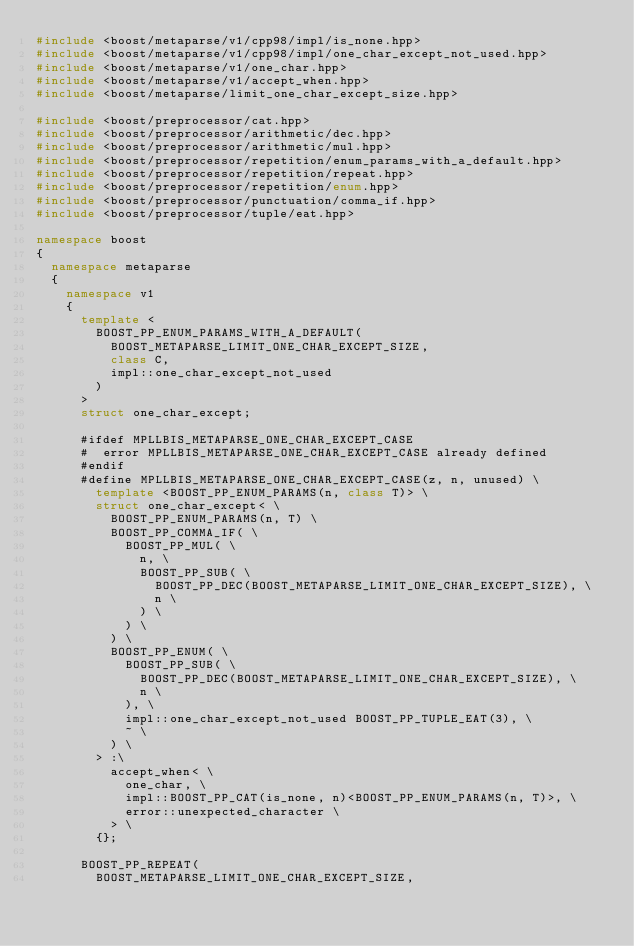Convert code to text. <code><loc_0><loc_0><loc_500><loc_500><_C++_>#include <boost/metaparse/v1/cpp98/impl/is_none.hpp>
#include <boost/metaparse/v1/cpp98/impl/one_char_except_not_used.hpp>
#include <boost/metaparse/v1/one_char.hpp>
#include <boost/metaparse/v1/accept_when.hpp>
#include <boost/metaparse/limit_one_char_except_size.hpp>

#include <boost/preprocessor/cat.hpp>
#include <boost/preprocessor/arithmetic/dec.hpp>
#include <boost/preprocessor/arithmetic/mul.hpp>
#include <boost/preprocessor/repetition/enum_params_with_a_default.hpp>
#include <boost/preprocessor/repetition/repeat.hpp>
#include <boost/preprocessor/repetition/enum.hpp>
#include <boost/preprocessor/punctuation/comma_if.hpp>
#include <boost/preprocessor/tuple/eat.hpp>

namespace boost
{
  namespace metaparse
  {
    namespace v1
    {
      template <
        BOOST_PP_ENUM_PARAMS_WITH_A_DEFAULT(
          BOOST_METAPARSE_LIMIT_ONE_CHAR_EXCEPT_SIZE,
          class C,
          impl::one_char_except_not_used
        )
      >
      struct one_char_except;

      #ifdef MPLLBIS_METAPARSE_ONE_CHAR_EXCEPT_CASE
      #  error MPLLBIS_METAPARSE_ONE_CHAR_EXCEPT_CASE already defined
      #endif
      #define MPLLBIS_METAPARSE_ONE_CHAR_EXCEPT_CASE(z, n, unused) \
        template <BOOST_PP_ENUM_PARAMS(n, class T)> \
        struct one_char_except< \
          BOOST_PP_ENUM_PARAMS(n, T) \
          BOOST_PP_COMMA_IF( \
            BOOST_PP_MUL( \
              n, \
              BOOST_PP_SUB( \
                BOOST_PP_DEC(BOOST_METAPARSE_LIMIT_ONE_CHAR_EXCEPT_SIZE), \
                n \
              ) \
            ) \
          ) \
          BOOST_PP_ENUM( \
            BOOST_PP_SUB( \
              BOOST_PP_DEC(BOOST_METAPARSE_LIMIT_ONE_CHAR_EXCEPT_SIZE), \
              n \
            ), \
            impl::one_char_except_not_used BOOST_PP_TUPLE_EAT(3), \
            ~ \
          ) \
        > :\
          accept_when< \
            one_char, \
            impl::BOOST_PP_CAT(is_none, n)<BOOST_PP_ENUM_PARAMS(n, T)>, \
            error::unexpected_character \
          > \
        {};

      BOOST_PP_REPEAT(
        BOOST_METAPARSE_LIMIT_ONE_CHAR_EXCEPT_SIZE,</code> 